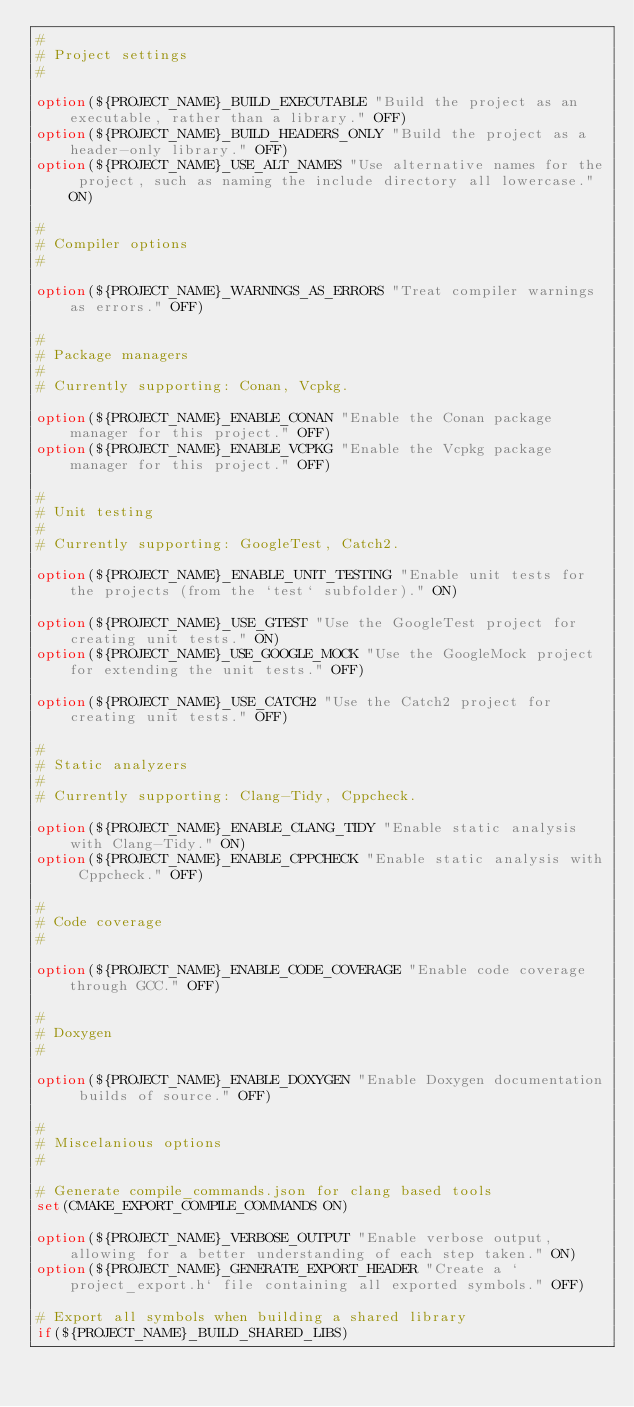<code> <loc_0><loc_0><loc_500><loc_500><_CMake_>#
# Project settings
#

option(${PROJECT_NAME}_BUILD_EXECUTABLE "Build the project as an executable, rather than a library." OFF)
option(${PROJECT_NAME}_BUILD_HEADERS_ONLY "Build the project as a header-only library." OFF)
option(${PROJECT_NAME}_USE_ALT_NAMES "Use alternative names for the project, such as naming the include directory all lowercase." ON)

#
# Compiler options
#

option(${PROJECT_NAME}_WARNINGS_AS_ERRORS "Treat compiler warnings as errors." OFF)

#
# Package managers
#
# Currently supporting: Conan, Vcpkg.

option(${PROJECT_NAME}_ENABLE_CONAN "Enable the Conan package manager for this project." OFF)
option(${PROJECT_NAME}_ENABLE_VCPKG "Enable the Vcpkg package manager for this project." OFF)

#
# Unit testing
#
# Currently supporting: GoogleTest, Catch2.

option(${PROJECT_NAME}_ENABLE_UNIT_TESTING "Enable unit tests for the projects (from the `test` subfolder)." ON)

option(${PROJECT_NAME}_USE_GTEST "Use the GoogleTest project for creating unit tests." ON)
option(${PROJECT_NAME}_USE_GOOGLE_MOCK "Use the GoogleMock project for extending the unit tests." OFF)

option(${PROJECT_NAME}_USE_CATCH2 "Use the Catch2 project for creating unit tests." OFF)

#
# Static analyzers
#
# Currently supporting: Clang-Tidy, Cppcheck.

option(${PROJECT_NAME}_ENABLE_CLANG_TIDY "Enable static analysis with Clang-Tidy." ON)
option(${PROJECT_NAME}_ENABLE_CPPCHECK "Enable static analysis with Cppcheck." OFF)

#
# Code coverage
#

option(${PROJECT_NAME}_ENABLE_CODE_COVERAGE "Enable code coverage through GCC." OFF)

#
# Doxygen
#

option(${PROJECT_NAME}_ENABLE_DOXYGEN "Enable Doxygen documentation builds of source." OFF)

#
# Miscelanious options
#

# Generate compile_commands.json for clang based tools
set(CMAKE_EXPORT_COMPILE_COMMANDS ON)

option(${PROJECT_NAME}_VERBOSE_OUTPUT "Enable verbose output, allowing for a better understanding of each step taken." ON)
option(${PROJECT_NAME}_GENERATE_EXPORT_HEADER "Create a `project_export.h` file containing all exported symbols." OFF)

# Export all symbols when building a shared library
if(${PROJECT_NAME}_BUILD_SHARED_LIBS)</code> 